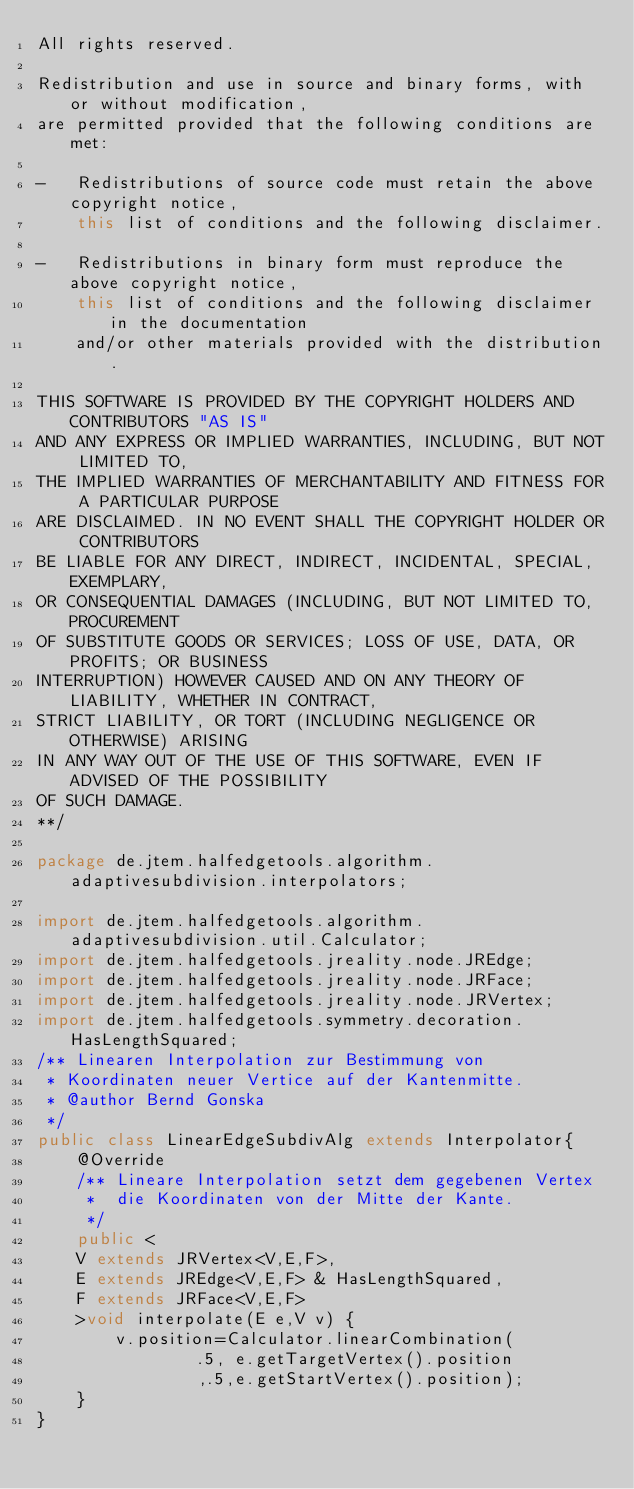Convert code to text. <code><loc_0><loc_0><loc_500><loc_500><_Java_>All rights reserved.

Redistribution and use in source and binary forms, with or without modification, 
are permitted provided that the following conditions are met:

-	Redistributions of source code must retain the above copyright notice, 
	this list of conditions and the following disclaimer.

-	Redistributions in binary form must reproduce the above copyright notice, 
	this list of conditions and the following disclaimer in the documentation 
	and/or other materials provided with the distribution.
 
THIS SOFTWARE IS PROVIDED BY THE COPYRIGHT HOLDERS AND CONTRIBUTORS "AS IS" 
AND ANY EXPRESS OR IMPLIED WARRANTIES, INCLUDING, BUT NOT LIMITED TO, 
THE IMPLIED WARRANTIES OF MERCHANTABILITY AND FITNESS FOR A PARTICULAR PURPOSE 
ARE DISCLAIMED. IN NO EVENT SHALL THE COPYRIGHT HOLDER OR CONTRIBUTORS 
BE LIABLE FOR ANY DIRECT, INDIRECT, INCIDENTAL, SPECIAL, EXEMPLARY, 
OR CONSEQUENTIAL DAMAGES (INCLUDING, BUT NOT LIMITED TO, PROCUREMENT 
OF SUBSTITUTE GOODS OR SERVICES; LOSS OF USE, DATA, OR PROFITS; OR BUSINESS 
INTERRUPTION) HOWEVER CAUSED AND ON ANY THEORY OF LIABILITY, WHETHER IN CONTRACT, 
STRICT LIABILITY, OR TORT (INCLUDING NEGLIGENCE OR OTHERWISE) ARISING 
IN ANY WAY OUT OF THE USE OF THIS SOFTWARE, EVEN IF ADVISED OF THE POSSIBILITY 
OF SUCH DAMAGE.
**/

package de.jtem.halfedgetools.algorithm.adaptivesubdivision.interpolators;

import de.jtem.halfedgetools.algorithm.adaptivesubdivision.util.Calculator;
import de.jtem.halfedgetools.jreality.node.JREdge;
import de.jtem.halfedgetools.jreality.node.JRFace;
import de.jtem.halfedgetools.jreality.node.JRVertex;
import de.jtem.halfedgetools.symmetry.decoration.HasLengthSquared;
/** Linearen Interpolation zur Bestimmung von 
 * Koordinaten neuer Vertice auf der Kantenmitte.
 * @author Bernd Gonska
 */
public class LinearEdgeSubdivAlg extends Interpolator{
	@Override
	/** Lineare Interpolation setzt dem gegebenen Vertex
	 *  die Koordinaten von der Mitte der Kante.
	 */
	public <
	V extends JRVertex<V,E,F>,
	E extends JREdge<V,E,F> & HasLengthSquared,
	F extends JRFace<V,E,F>
	>void interpolate(E e,V v) {	
		v.position=Calculator.linearCombination(
				.5, e.getTargetVertex().position
				,.5,e.getStartVertex().position);
	}
}
</code> 